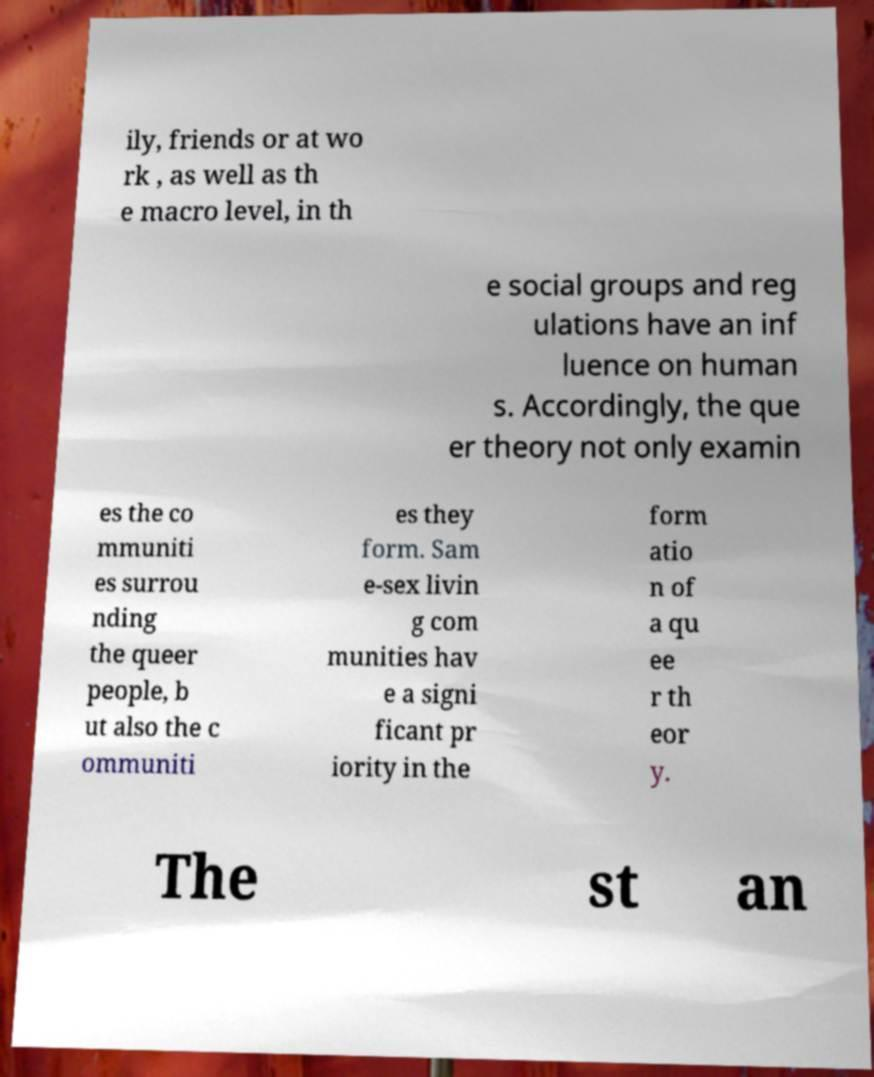There's text embedded in this image that I need extracted. Can you transcribe it verbatim? ily, friends or at wo rk , as well as th e macro level, in th e social groups and reg ulations have an inf luence on human s. Accordingly, the que er theory not only examin es the co mmuniti es surrou nding the queer people, b ut also the c ommuniti es they form. Sam e-sex livin g com munities hav e a signi ficant pr iority in the form atio n of a qu ee r th eor y. The st an 